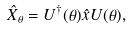<formula> <loc_0><loc_0><loc_500><loc_500>\hat { X } _ { \theta } = U ^ { \dagger } ( \theta ) \hat { x } U ( \theta ) ,</formula> 